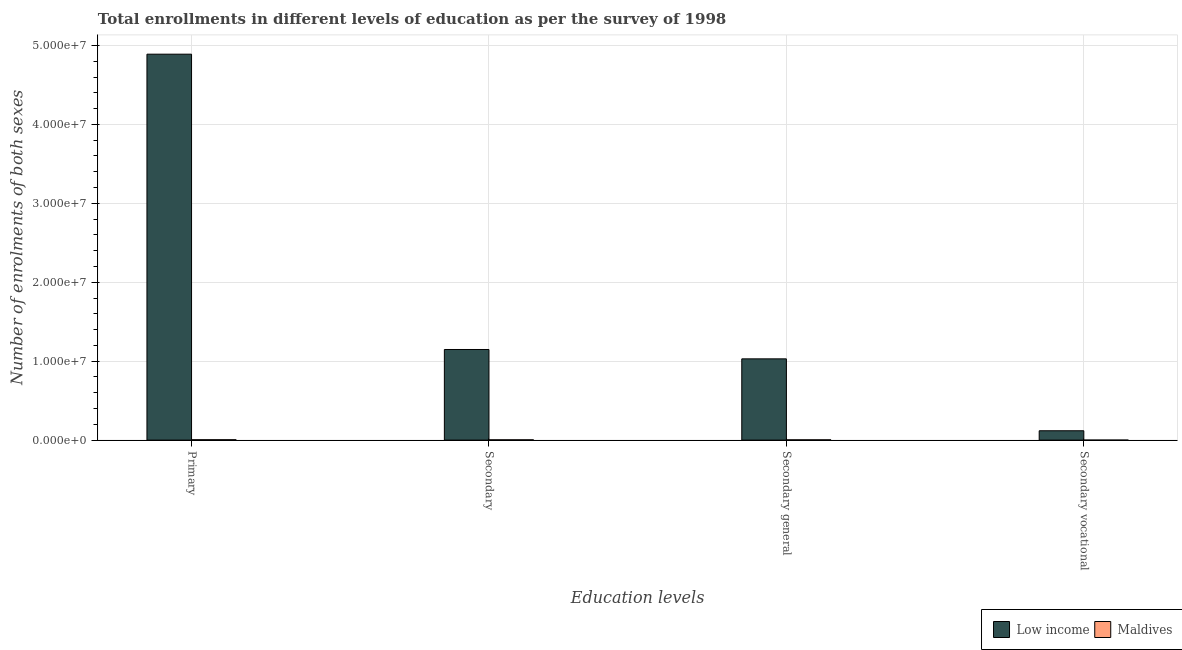How many different coloured bars are there?
Provide a succinct answer. 2. How many groups of bars are there?
Give a very brief answer. 4. Are the number of bars per tick equal to the number of legend labels?
Make the answer very short. Yes. What is the label of the 3rd group of bars from the left?
Provide a short and direct response. Secondary general. What is the number of enrolments in secondary education in Low income?
Keep it short and to the point. 1.15e+07. Across all countries, what is the maximum number of enrolments in secondary vocational education?
Make the answer very short. 1.18e+06. Across all countries, what is the minimum number of enrolments in secondary general education?
Ensure brevity in your answer.  3.62e+04. In which country was the number of enrolments in secondary education minimum?
Your answer should be compact. Maldives. What is the total number of enrolments in secondary general education in the graph?
Give a very brief answer. 1.03e+07. What is the difference between the number of enrolments in primary education in Low income and that in Maldives?
Your response must be concise. 4.88e+07. What is the difference between the number of enrolments in secondary vocational education in Maldives and the number of enrolments in primary education in Low income?
Provide a short and direct response. -4.89e+07. What is the average number of enrolments in secondary vocational education per country?
Offer a terse response. 5.93e+05. What is the difference between the number of enrolments in primary education and number of enrolments in secondary education in Maldives?
Provide a succinct answer. 1.20e+04. In how many countries, is the number of enrolments in secondary general education greater than 16000000 ?
Make the answer very short. 0. What is the ratio of the number of enrolments in secondary vocational education in Low income to that in Maldives?
Provide a short and direct response. 1808.69. Is the number of enrolments in secondary education in Maldives less than that in Low income?
Offer a terse response. Yes. Is the difference between the number of enrolments in secondary vocational education in Low income and Maldives greater than the difference between the number of enrolments in secondary general education in Low income and Maldives?
Keep it short and to the point. No. What is the difference between the highest and the second highest number of enrolments in secondary vocational education?
Your answer should be compact. 1.18e+06. What is the difference between the highest and the lowest number of enrolments in secondary education?
Provide a short and direct response. 1.14e+07. Is the sum of the number of enrolments in secondary vocational education in Maldives and Low income greater than the maximum number of enrolments in secondary education across all countries?
Offer a terse response. No. What does the 2nd bar from the left in Secondary represents?
Make the answer very short. Maldives. How many bars are there?
Ensure brevity in your answer.  8. Are all the bars in the graph horizontal?
Your answer should be compact. No. Are the values on the major ticks of Y-axis written in scientific E-notation?
Offer a terse response. Yes. Does the graph contain any zero values?
Make the answer very short. No. Does the graph contain grids?
Provide a short and direct response. Yes. Where does the legend appear in the graph?
Keep it short and to the point. Bottom right. How are the legend labels stacked?
Provide a short and direct response. Horizontal. What is the title of the graph?
Ensure brevity in your answer.  Total enrollments in different levels of education as per the survey of 1998. Does "Central Europe" appear as one of the legend labels in the graph?
Your answer should be compact. No. What is the label or title of the X-axis?
Make the answer very short. Education levels. What is the label or title of the Y-axis?
Ensure brevity in your answer.  Number of enrolments of both sexes. What is the Number of enrolments of both sexes of Low income in Primary?
Your answer should be compact. 4.89e+07. What is the Number of enrolments of both sexes of Maldives in Primary?
Ensure brevity in your answer.  4.89e+04. What is the Number of enrolments of both sexes in Low income in Secondary?
Your response must be concise. 1.15e+07. What is the Number of enrolments of both sexes in Maldives in Secondary?
Provide a short and direct response. 3.69e+04. What is the Number of enrolments of both sexes of Low income in Secondary general?
Your response must be concise. 1.03e+07. What is the Number of enrolments of both sexes in Maldives in Secondary general?
Keep it short and to the point. 3.62e+04. What is the Number of enrolments of both sexes of Low income in Secondary vocational?
Provide a succinct answer. 1.18e+06. What is the Number of enrolments of both sexes of Maldives in Secondary vocational?
Make the answer very short. 655. Across all Education levels, what is the maximum Number of enrolments of both sexes in Low income?
Offer a very short reply. 4.89e+07. Across all Education levels, what is the maximum Number of enrolments of both sexes of Maldives?
Your response must be concise. 4.89e+04. Across all Education levels, what is the minimum Number of enrolments of both sexes of Low income?
Your response must be concise. 1.18e+06. Across all Education levels, what is the minimum Number of enrolments of both sexes in Maldives?
Give a very brief answer. 655. What is the total Number of enrolments of both sexes in Low income in the graph?
Offer a terse response. 7.19e+07. What is the total Number of enrolments of both sexes in Maldives in the graph?
Give a very brief answer. 1.23e+05. What is the difference between the Number of enrolments of both sexes in Low income in Primary and that in Secondary?
Provide a succinct answer. 3.74e+07. What is the difference between the Number of enrolments of both sexes of Maldives in Primary and that in Secondary?
Ensure brevity in your answer.  1.20e+04. What is the difference between the Number of enrolments of both sexes in Low income in Primary and that in Secondary general?
Make the answer very short. 3.86e+07. What is the difference between the Number of enrolments of both sexes in Maldives in Primary and that in Secondary general?
Give a very brief answer. 1.26e+04. What is the difference between the Number of enrolments of both sexes in Low income in Primary and that in Secondary vocational?
Your answer should be very brief. 4.77e+07. What is the difference between the Number of enrolments of both sexes of Maldives in Primary and that in Secondary vocational?
Your answer should be very brief. 4.82e+04. What is the difference between the Number of enrolments of both sexes of Low income in Secondary and that in Secondary general?
Offer a very short reply. 1.18e+06. What is the difference between the Number of enrolments of both sexes in Maldives in Secondary and that in Secondary general?
Provide a short and direct response. 655. What is the difference between the Number of enrolments of both sexes in Low income in Secondary and that in Secondary vocational?
Your answer should be compact. 1.03e+07. What is the difference between the Number of enrolments of both sexes in Maldives in Secondary and that in Secondary vocational?
Give a very brief answer. 3.62e+04. What is the difference between the Number of enrolments of both sexes of Low income in Secondary general and that in Secondary vocational?
Your answer should be compact. 9.11e+06. What is the difference between the Number of enrolments of both sexes of Maldives in Secondary general and that in Secondary vocational?
Give a very brief answer. 3.56e+04. What is the difference between the Number of enrolments of both sexes in Low income in Primary and the Number of enrolments of both sexes in Maldives in Secondary?
Provide a succinct answer. 4.89e+07. What is the difference between the Number of enrolments of both sexes in Low income in Primary and the Number of enrolments of both sexes in Maldives in Secondary general?
Offer a very short reply. 4.89e+07. What is the difference between the Number of enrolments of both sexes in Low income in Primary and the Number of enrolments of both sexes in Maldives in Secondary vocational?
Make the answer very short. 4.89e+07. What is the difference between the Number of enrolments of both sexes of Low income in Secondary and the Number of enrolments of both sexes of Maldives in Secondary general?
Ensure brevity in your answer.  1.14e+07. What is the difference between the Number of enrolments of both sexes in Low income in Secondary and the Number of enrolments of both sexes in Maldives in Secondary vocational?
Your answer should be compact. 1.15e+07. What is the difference between the Number of enrolments of both sexes of Low income in Secondary general and the Number of enrolments of both sexes of Maldives in Secondary vocational?
Offer a terse response. 1.03e+07. What is the average Number of enrolments of both sexes of Low income per Education levels?
Offer a very short reply. 1.80e+07. What is the average Number of enrolments of both sexes in Maldives per Education levels?
Your answer should be compact. 3.07e+04. What is the difference between the Number of enrolments of both sexes of Low income and Number of enrolments of both sexes of Maldives in Primary?
Your answer should be very brief. 4.88e+07. What is the difference between the Number of enrolments of both sexes of Low income and Number of enrolments of both sexes of Maldives in Secondary?
Make the answer very short. 1.14e+07. What is the difference between the Number of enrolments of both sexes of Low income and Number of enrolments of both sexes of Maldives in Secondary general?
Your response must be concise. 1.03e+07. What is the difference between the Number of enrolments of both sexes in Low income and Number of enrolments of both sexes in Maldives in Secondary vocational?
Your response must be concise. 1.18e+06. What is the ratio of the Number of enrolments of both sexes of Low income in Primary to that in Secondary?
Make the answer very short. 4.26. What is the ratio of the Number of enrolments of both sexes of Maldives in Primary to that in Secondary?
Your answer should be compact. 1.32. What is the ratio of the Number of enrolments of both sexes of Low income in Primary to that in Secondary general?
Your answer should be very brief. 4.75. What is the ratio of the Number of enrolments of both sexes of Maldives in Primary to that in Secondary general?
Your response must be concise. 1.35. What is the ratio of the Number of enrolments of both sexes of Low income in Primary to that in Secondary vocational?
Make the answer very short. 41.27. What is the ratio of the Number of enrolments of both sexes of Maldives in Primary to that in Secondary vocational?
Your response must be concise. 74.65. What is the ratio of the Number of enrolments of both sexes in Low income in Secondary to that in Secondary general?
Offer a very short reply. 1.12. What is the ratio of the Number of enrolments of both sexes of Maldives in Secondary to that in Secondary general?
Provide a short and direct response. 1.02. What is the ratio of the Number of enrolments of both sexes in Low income in Secondary to that in Secondary vocational?
Keep it short and to the point. 9.69. What is the ratio of the Number of enrolments of both sexes of Maldives in Secondary to that in Secondary vocational?
Your answer should be compact. 56.34. What is the ratio of the Number of enrolments of both sexes of Low income in Secondary general to that in Secondary vocational?
Give a very brief answer. 8.69. What is the ratio of the Number of enrolments of both sexes in Maldives in Secondary general to that in Secondary vocational?
Ensure brevity in your answer.  55.34. What is the difference between the highest and the second highest Number of enrolments of both sexes of Low income?
Make the answer very short. 3.74e+07. What is the difference between the highest and the second highest Number of enrolments of both sexes in Maldives?
Offer a very short reply. 1.20e+04. What is the difference between the highest and the lowest Number of enrolments of both sexes of Low income?
Offer a terse response. 4.77e+07. What is the difference between the highest and the lowest Number of enrolments of both sexes of Maldives?
Make the answer very short. 4.82e+04. 